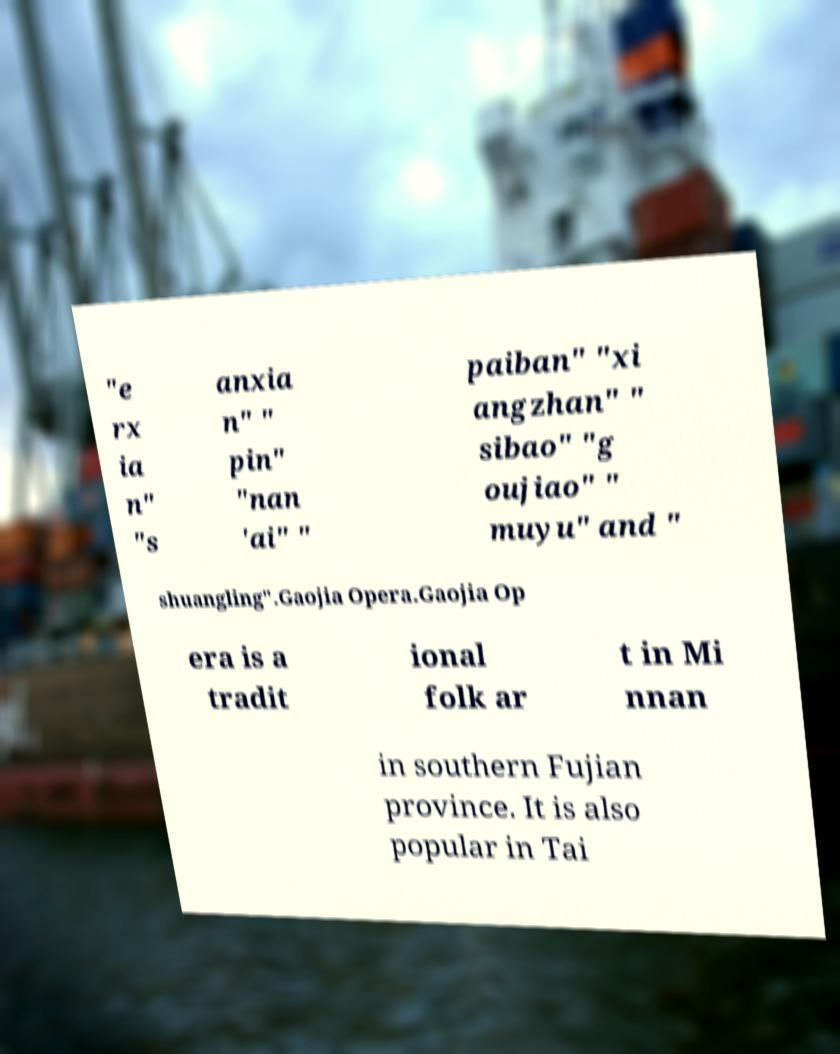Could you extract and type out the text from this image? "e rx ia n" "s anxia n" " pin" "nan 'ai" " paiban" "xi angzhan" " sibao" "g oujiao" " muyu" and " shuangling".Gaojia Opera.Gaojia Op era is a tradit ional folk ar t in Mi nnan in southern Fujian province. It is also popular in Tai 